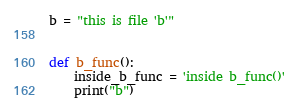Convert code to text. <code><loc_0><loc_0><loc_500><loc_500><_Python_>b = "this is file 'b'"


def b_func():
    inside_b_func = 'inside b_func()'
    print("b")
</code> 